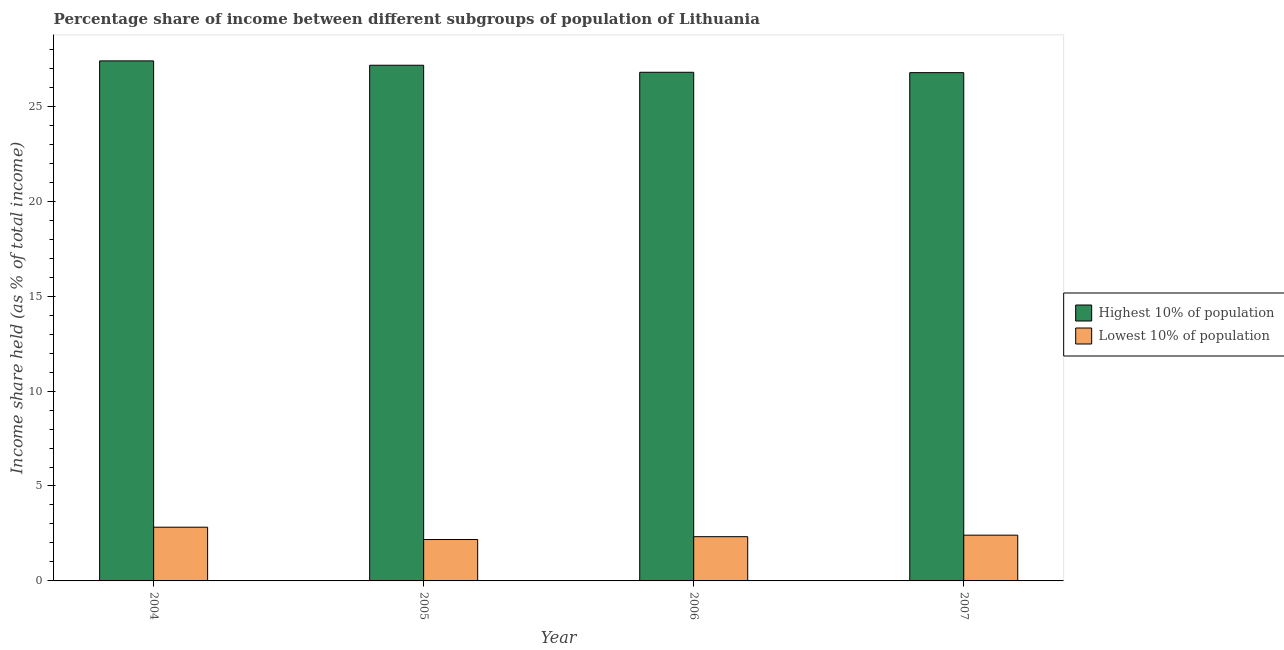Are the number of bars per tick equal to the number of legend labels?
Keep it short and to the point. Yes. How many bars are there on the 1st tick from the right?
Provide a short and direct response. 2. In how many cases, is the number of bars for a given year not equal to the number of legend labels?
Your answer should be compact. 0. What is the income share held by highest 10% of the population in 2005?
Your answer should be very brief. 27.16. Across all years, what is the maximum income share held by lowest 10% of the population?
Provide a succinct answer. 2.83. Across all years, what is the minimum income share held by highest 10% of the population?
Offer a very short reply. 26.77. In which year was the income share held by highest 10% of the population minimum?
Keep it short and to the point. 2007. What is the total income share held by lowest 10% of the population in the graph?
Keep it short and to the point. 9.75. What is the difference between the income share held by highest 10% of the population in 2005 and that in 2006?
Your answer should be very brief. 0.37. What is the difference between the income share held by highest 10% of the population in 2006 and the income share held by lowest 10% of the population in 2004?
Offer a very short reply. -0.6. What is the average income share held by lowest 10% of the population per year?
Ensure brevity in your answer.  2.44. In how many years, is the income share held by lowest 10% of the population greater than 18 %?
Your answer should be compact. 0. What is the ratio of the income share held by lowest 10% of the population in 2005 to that in 2006?
Ensure brevity in your answer.  0.94. Is the income share held by lowest 10% of the population in 2004 less than that in 2005?
Give a very brief answer. No. Is the difference between the income share held by lowest 10% of the population in 2005 and 2007 greater than the difference between the income share held by highest 10% of the population in 2005 and 2007?
Keep it short and to the point. No. What is the difference between the highest and the second highest income share held by highest 10% of the population?
Ensure brevity in your answer.  0.23. What is the difference between the highest and the lowest income share held by lowest 10% of the population?
Provide a short and direct response. 0.65. Is the sum of the income share held by highest 10% of the population in 2004 and 2006 greater than the maximum income share held by lowest 10% of the population across all years?
Your answer should be very brief. Yes. What does the 1st bar from the left in 2005 represents?
Your answer should be compact. Highest 10% of population. What does the 2nd bar from the right in 2004 represents?
Offer a very short reply. Highest 10% of population. How many bars are there?
Give a very brief answer. 8. Are all the bars in the graph horizontal?
Offer a very short reply. No. Where does the legend appear in the graph?
Offer a very short reply. Center right. How are the legend labels stacked?
Make the answer very short. Vertical. What is the title of the graph?
Offer a terse response. Percentage share of income between different subgroups of population of Lithuania. Does "Highest 10% of population" appear as one of the legend labels in the graph?
Your response must be concise. Yes. What is the label or title of the Y-axis?
Make the answer very short. Income share held (as % of total income). What is the Income share held (as % of total income) in Highest 10% of population in 2004?
Your response must be concise. 27.39. What is the Income share held (as % of total income) of Lowest 10% of population in 2004?
Ensure brevity in your answer.  2.83. What is the Income share held (as % of total income) in Highest 10% of population in 2005?
Keep it short and to the point. 27.16. What is the Income share held (as % of total income) in Lowest 10% of population in 2005?
Give a very brief answer. 2.18. What is the Income share held (as % of total income) of Highest 10% of population in 2006?
Ensure brevity in your answer.  26.79. What is the Income share held (as % of total income) of Lowest 10% of population in 2006?
Your response must be concise. 2.33. What is the Income share held (as % of total income) of Highest 10% of population in 2007?
Offer a terse response. 26.77. What is the Income share held (as % of total income) in Lowest 10% of population in 2007?
Provide a succinct answer. 2.41. Across all years, what is the maximum Income share held (as % of total income) of Highest 10% of population?
Offer a very short reply. 27.39. Across all years, what is the maximum Income share held (as % of total income) in Lowest 10% of population?
Your answer should be compact. 2.83. Across all years, what is the minimum Income share held (as % of total income) of Highest 10% of population?
Give a very brief answer. 26.77. Across all years, what is the minimum Income share held (as % of total income) in Lowest 10% of population?
Your answer should be compact. 2.18. What is the total Income share held (as % of total income) in Highest 10% of population in the graph?
Ensure brevity in your answer.  108.11. What is the total Income share held (as % of total income) in Lowest 10% of population in the graph?
Offer a terse response. 9.75. What is the difference between the Income share held (as % of total income) in Highest 10% of population in 2004 and that in 2005?
Ensure brevity in your answer.  0.23. What is the difference between the Income share held (as % of total income) in Lowest 10% of population in 2004 and that in 2005?
Your answer should be very brief. 0.65. What is the difference between the Income share held (as % of total income) in Lowest 10% of population in 2004 and that in 2006?
Offer a very short reply. 0.5. What is the difference between the Income share held (as % of total income) of Highest 10% of population in 2004 and that in 2007?
Your answer should be compact. 0.62. What is the difference between the Income share held (as % of total income) of Lowest 10% of population in 2004 and that in 2007?
Your answer should be compact. 0.42. What is the difference between the Income share held (as % of total income) in Highest 10% of population in 2005 and that in 2006?
Ensure brevity in your answer.  0.37. What is the difference between the Income share held (as % of total income) of Lowest 10% of population in 2005 and that in 2006?
Offer a terse response. -0.15. What is the difference between the Income share held (as % of total income) in Highest 10% of population in 2005 and that in 2007?
Your answer should be very brief. 0.39. What is the difference between the Income share held (as % of total income) in Lowest 10% of population in 2005 and that in 2007?
Keep it short and to the point. -0.23. What is the difference between the Income share held (as % of total income) of Lowest 10% of population in 2006 and that in 2007?
Your answer should be compact. -0.08. What is the difference between the Income share held (as % of total income) of Highest 10% of population in 2004 and the Income share held (as % of total income) of Lowest 10% of population in 2005?
Provide a short and direct response. 25.21. What is the difference between the Income share held (as % of total income) of Highest 10% of population in 2004 and the Income share held (as % of total income) of Lowest 10% of population in 2006?
Offer a terse response. 25.06. What is the difference between the Income share held (as % of total income) in Highest 10% of population in 2004 and the Income share held (as % of total income) in Lowest 10% of population in 2007?
Your answer should be very brief. 24.98. What is the difference between the Income share held (as % of total income) in Highest 10% of population in 2005 and the Income share held (as % of total income) in Lowest 10% of population in 2006?
Your answer should be very brief. 24.83. What is the difference between the Income share held (as % of total income) of Highest 10% of population in 2005 and the Income share held (as % of total income) of Lowest 10% of population in 2007?
Keep it short and to the point. 24.75. What is the difference between the Income share held (as % of total income) in Highest 10% of population in 2006 and the Income share held (as % of total income) in Lowest 10% of population in 2007?
Offer a very short reply. 24.38. What is the average Income share held (as % of total income) of Highest 10% of population per year?
Give a very brief answer. 27.03. What is the average Income share held (as % of total income) in Lowest 10% of population per year?
Offer a very short reply. 2.44. In the year 2004, what is the difference between the Income share held (as % of total income) of Highest 10% of population and Income share held (as % of total income) of Lowest 10% of population?
Your response must be concise. 24.56. In the year 2005, what is the difference between the Income share held (as % of total income) of Highest 10% of population and Income share held (as % of total income) of Lowest 10% of population?
Offer a very short reply. 24.98. In the year 2006, what is the difference between the Income share held (as % of total income) in Highest 10% of population and Income share held (as % of total income) in Lowest 10% of population?
Give a very brief answer. 24.46. In the year 2007, what is the difference between the Income share held (as % of total income) of Highest 10% of population and Income share held (as % of total income) of Lowest 10% of population?
Offer a very short reply. 24.36. What is the ratio of the Income share held (as % of total income) in Highest 10% of population in 2004 to that in 2005?
Your answer should be very brief. 1.01. What is the ratio of the Income share held (as % of total income) of Lowest 10% of population in 2004 to that in 2005?
Offer a very short reply. 1.3. What is the ratio of the Income share held (as % of total income) of Highest 10% of population in 2004 to that in 2006?
Ensure brevity in your answer.  1.02. What is the ratio of the Income share held (as % of total income) of Lowest 10% of population in 2004 to that in 2006?
Your response must be concise. 1.21. What is the ratio of the Income share held (as % of total income) of Highest 10% of population in 2004 to that in 2007?
Offer a very short reply. 1.02. What is the ratio of the Income share held (as % of total income) in Lowest 10% of population in 2004 to that in 2007?
Keep it short and to the point. 1.17. What is the ratio of the Income share held (as % of total income) in Highest 10% of population in 2005 to that in 2006?
Your answer should be very brief. 1.01. What is the ratio of the Income share held (as % of total income) of Lowest 10% of population in 2005 to that in 2006?
Offer a very short reply. 0.94. What is the ratio of the Income share held (as % of total income) of Highest 10% of population in 2005 to that in 2007?
Provide a short and direct response. 1.01. What is the ratio of the Income share held (as % of total income) of Lowest 10% of population in 2005 to that in 2007?
Ensure brevity in your answer.  0.9. What is the ratio of the Income share held (as % of total income) of Lowest 10% of population in 2006 to that in 2007?
Provide a succinct answer. 0.97. What is the difference between the highest and the second highest Income share held (as % of total income) in Highest 10% of population?
Ensure brevity in your answer.  0.23. What is the difference between the highest and the second highest Income share held (as % of total income) in Lowest 10% of population?
Offer a terse response. 0.42. What is the difference between the highest and the lowest Income share held (as % of total income) in Highest 10% of population?
Offer a terse response. 0.62. What is the difference between the highest and the lowest Income share held (as % of total income) of Lowest 10% of population?
Offer a very short reply. 0.65. 